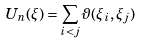<formula> <loc_0><loc_0><loc_500><loc_500>U _ { n } ( \xi ) = \sum _ { i < j } \vartheta ( \xi _ { i } , \xi _ { j } )</formula> 